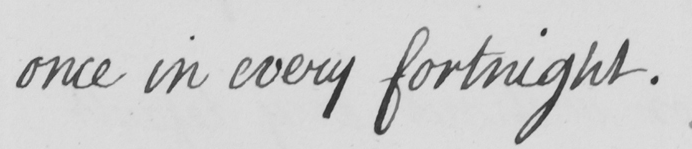Can you tell me what this handwritten text says? once in every fortnight . 